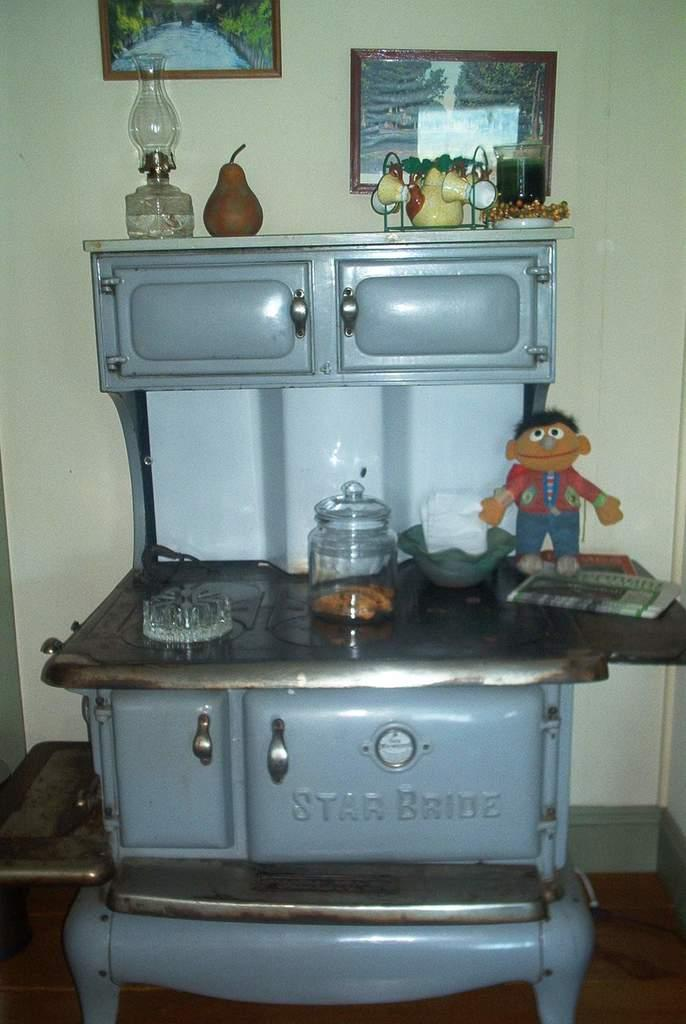<image>
Share a concise interpretation of the image provided. An old stove with Star Bride printed on the front door. 